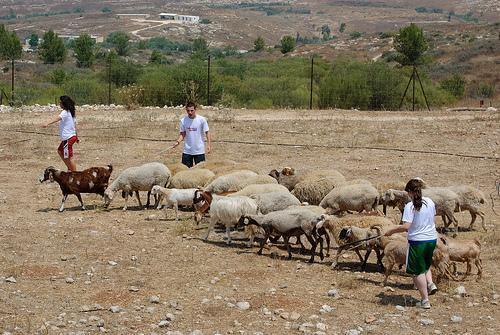How many brown goats are there?
Give a very brief answer. 2. 